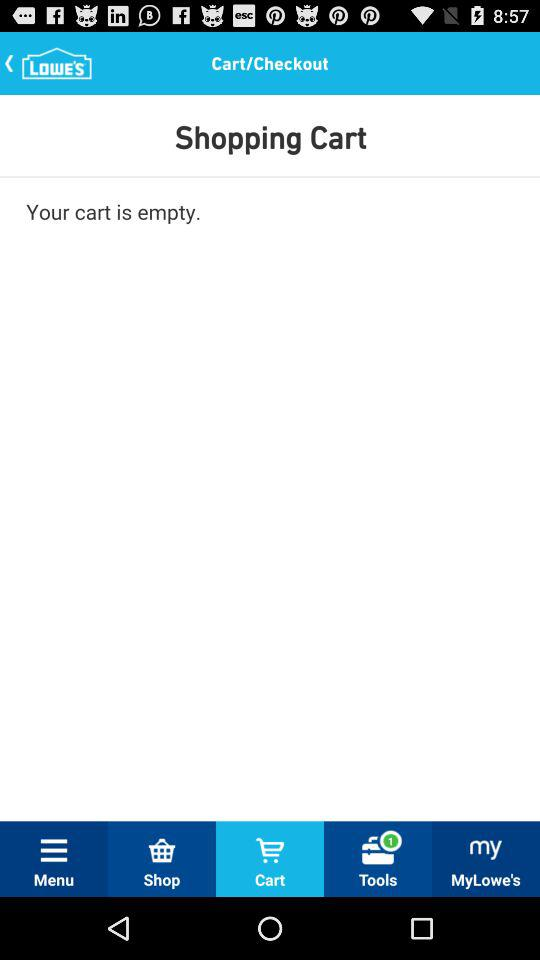What is the name of the application? The name of the application is "LOWE'S". 